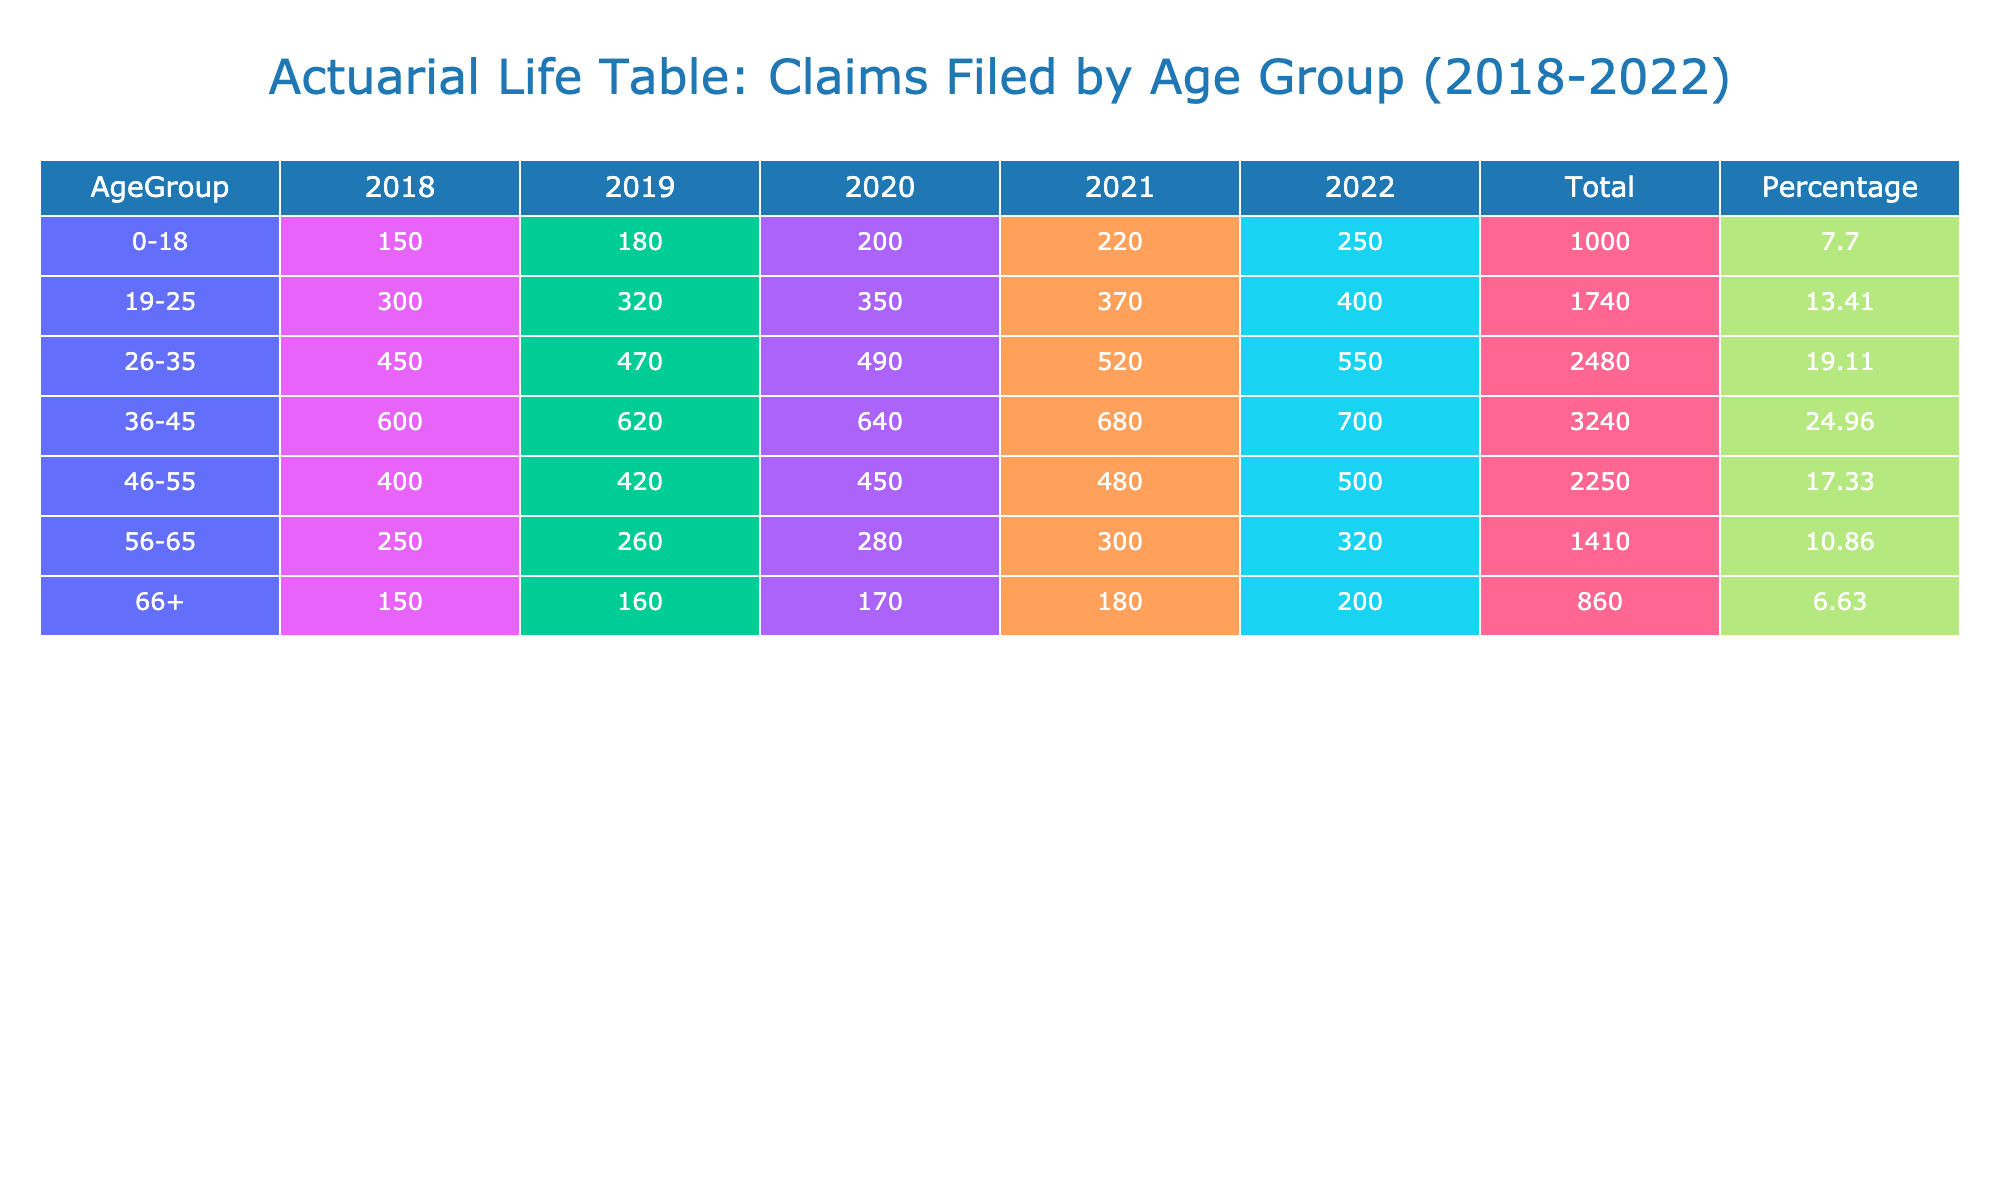What was the total number of claims filed by the age group 19-25 over the five years? The total claims for the age group 19-25 can be found by adding the claims filed in each year from 2018 to 2022. The claims are 300 (2018), 320 (2019), 350 (2020), 370 (2021), and 400 (2022). Summing these values gives: 300 + 320 + 350 + 370 + 400 = 1740.
Answer: 1740 Which age group had the highest number of claims filed in 2022? To find the age group with the highest claims in 2022, we look at the claims filed by each age group specifically for that year. The claims for 2022 are: 250 (0-18), 400 (19-25), 550 (26-35), 700 (36-45), 500 (46-55), 320 (56-65), and 200 (66+). The highest value is 700 from the 36-45 age group.
Answer: 36-45 What is the percentage of total claims that the age group 46-55 represented over the five years? First, we find the total claims filed by the age group 46-55: 400 (2018) + 420 (2019) + 450 (2020) + 480 (2021) + 500 (2022) = 2250. The overall total claims across all age groups is 10000 (when calculating the total claims for all age groups). Next, we calculate the percentage: (2250 / 10000) * 100 = 22.5%.
Answer: 22.5% Did the age group 0-18 experience an increase in claims filed every year from 2018 to 2022? To verify this, we check the claims filed by the 0-18 age group each year: 150 (2018), 180 (2019), 200 (2020), 220 (2021), and 250 (2022). Each successive year shows an increase in claims, confirming that this age group did experience an increase every year.
Answer: Yes What was the average number of claims filed by the age group 56-65 over the five years? We determine the claims for the age group 56-65: 250 (2018), 260 (2019), 280 (2020), 300 (2021), and 320 (2022). The total claims are 250 + 260 + 280 + 300 + 320 = 1410. To find the average, we divide by the number of years, which is 5: 1410 / 5 = 282.
Answer: 282 